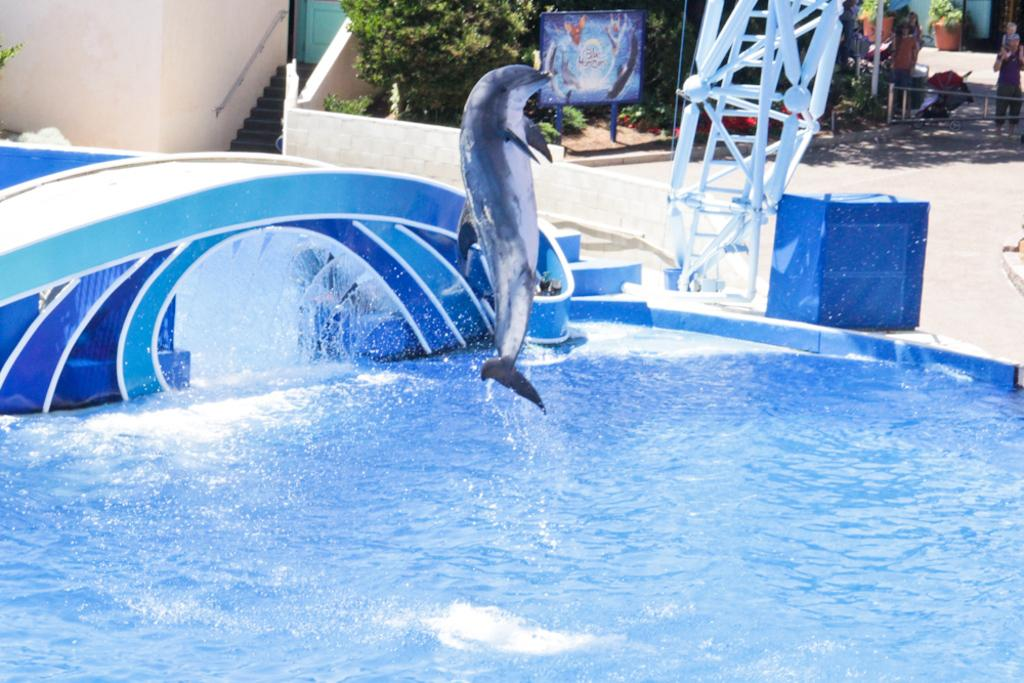What animal can be seen in the image? There is a dolphin in the image. What is the primary element in which the dolphin is situated? The dolphin is situated in water, which is visible in the image. What can be seen in the background of the image? There are people, a board, plants, steps, and a wall in the background of the image. What type of request can be seen written on the brick in the image? There is no brick present in the image, and therefore no request can be seen written on it. 